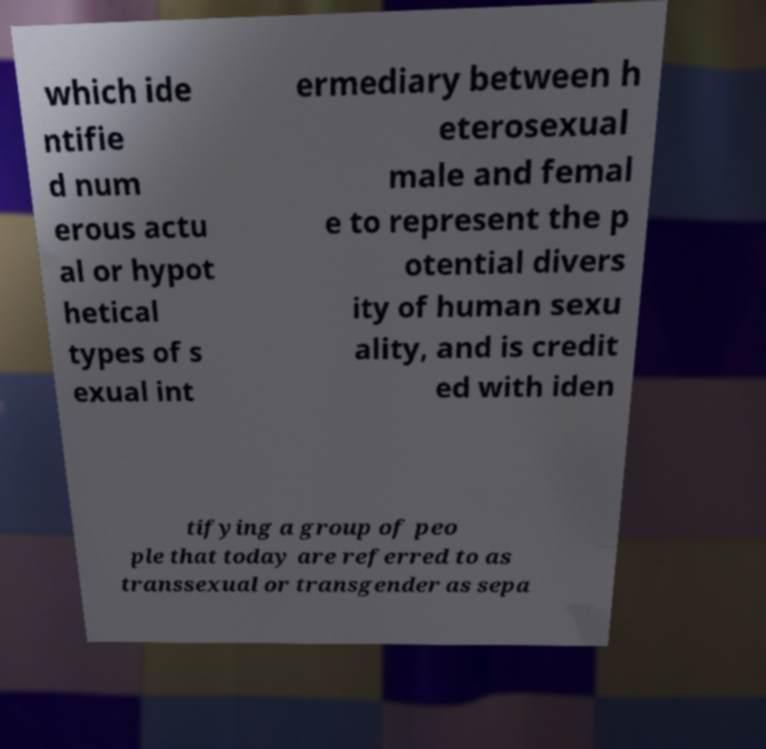For documentation purposes, I need the text within this image transcribed. Could you provide that? which ide ntifie d num erous actu al or hypot hetical types of s exual int ermediary between h eterosexual male and femal e to represent the p otential divers ity of human sexu ality, and is credit ed with iden tifying a group of peo ple that today are referred to as transsexual or transgender as sepa 